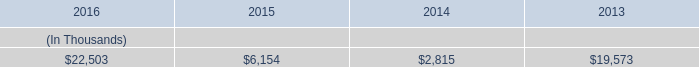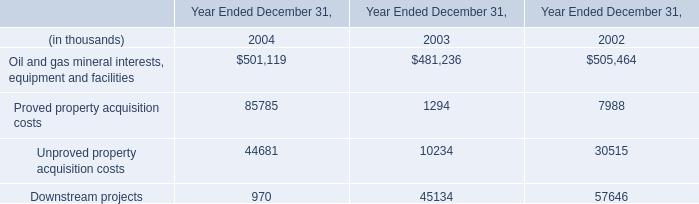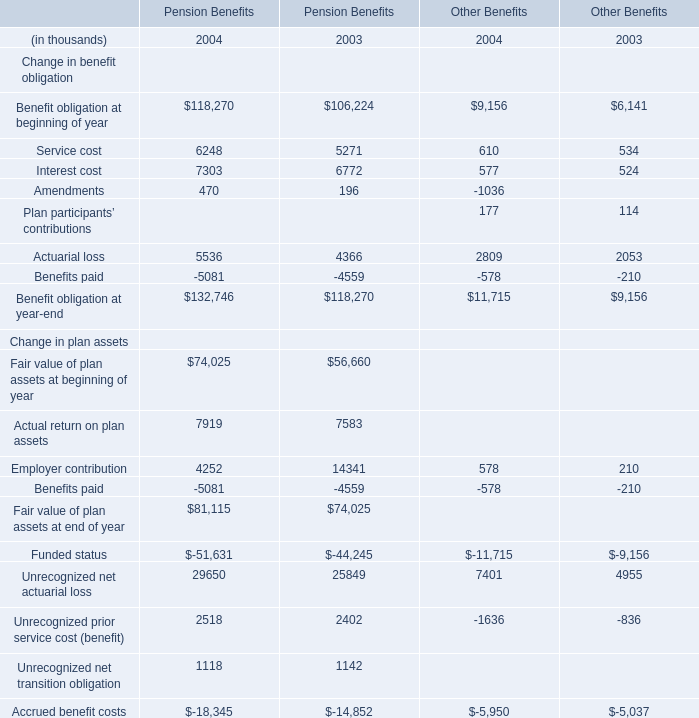if the entergy louisiana commitment for customer benefits was limited to four years , how much would customers receive in millions? 
Computations: (((6.2 + 6.2) + 6.2) + 6.2)
Answer: 24.8. 